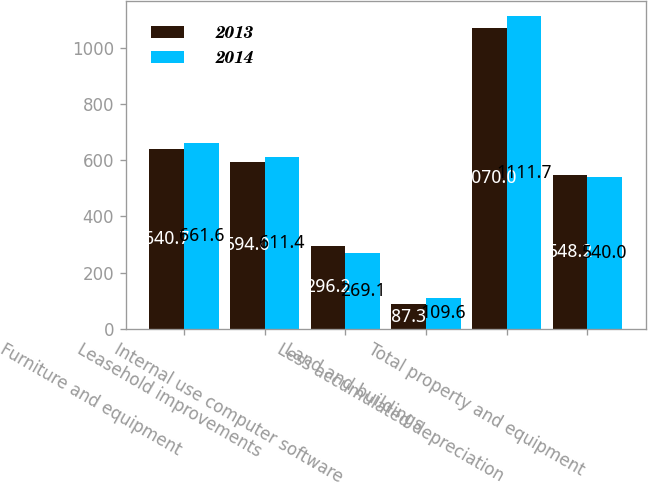Convert chart. <chart><loc_0><loc_0><loc_500><loc_500><stacked_bar_chart><ecel><fcel>Furniture and equipment<fcel>Leasehold improvements<fcel>Internal use computer software<fcel>Land and buildings<fcel>Less accumulated depreciation<fcel>Total property and equipment<nl><fcel>2013<fcel>640.7<fcel>594<fcel>296.2<fcel>87.3<fcel>1070<fcel>548.2<nl><fcel>2014<fcel>661.6<fcel>611.4<fcel>269.1<fcel>109.6<fcel>1111.7<fcel>540<nl></chart> 